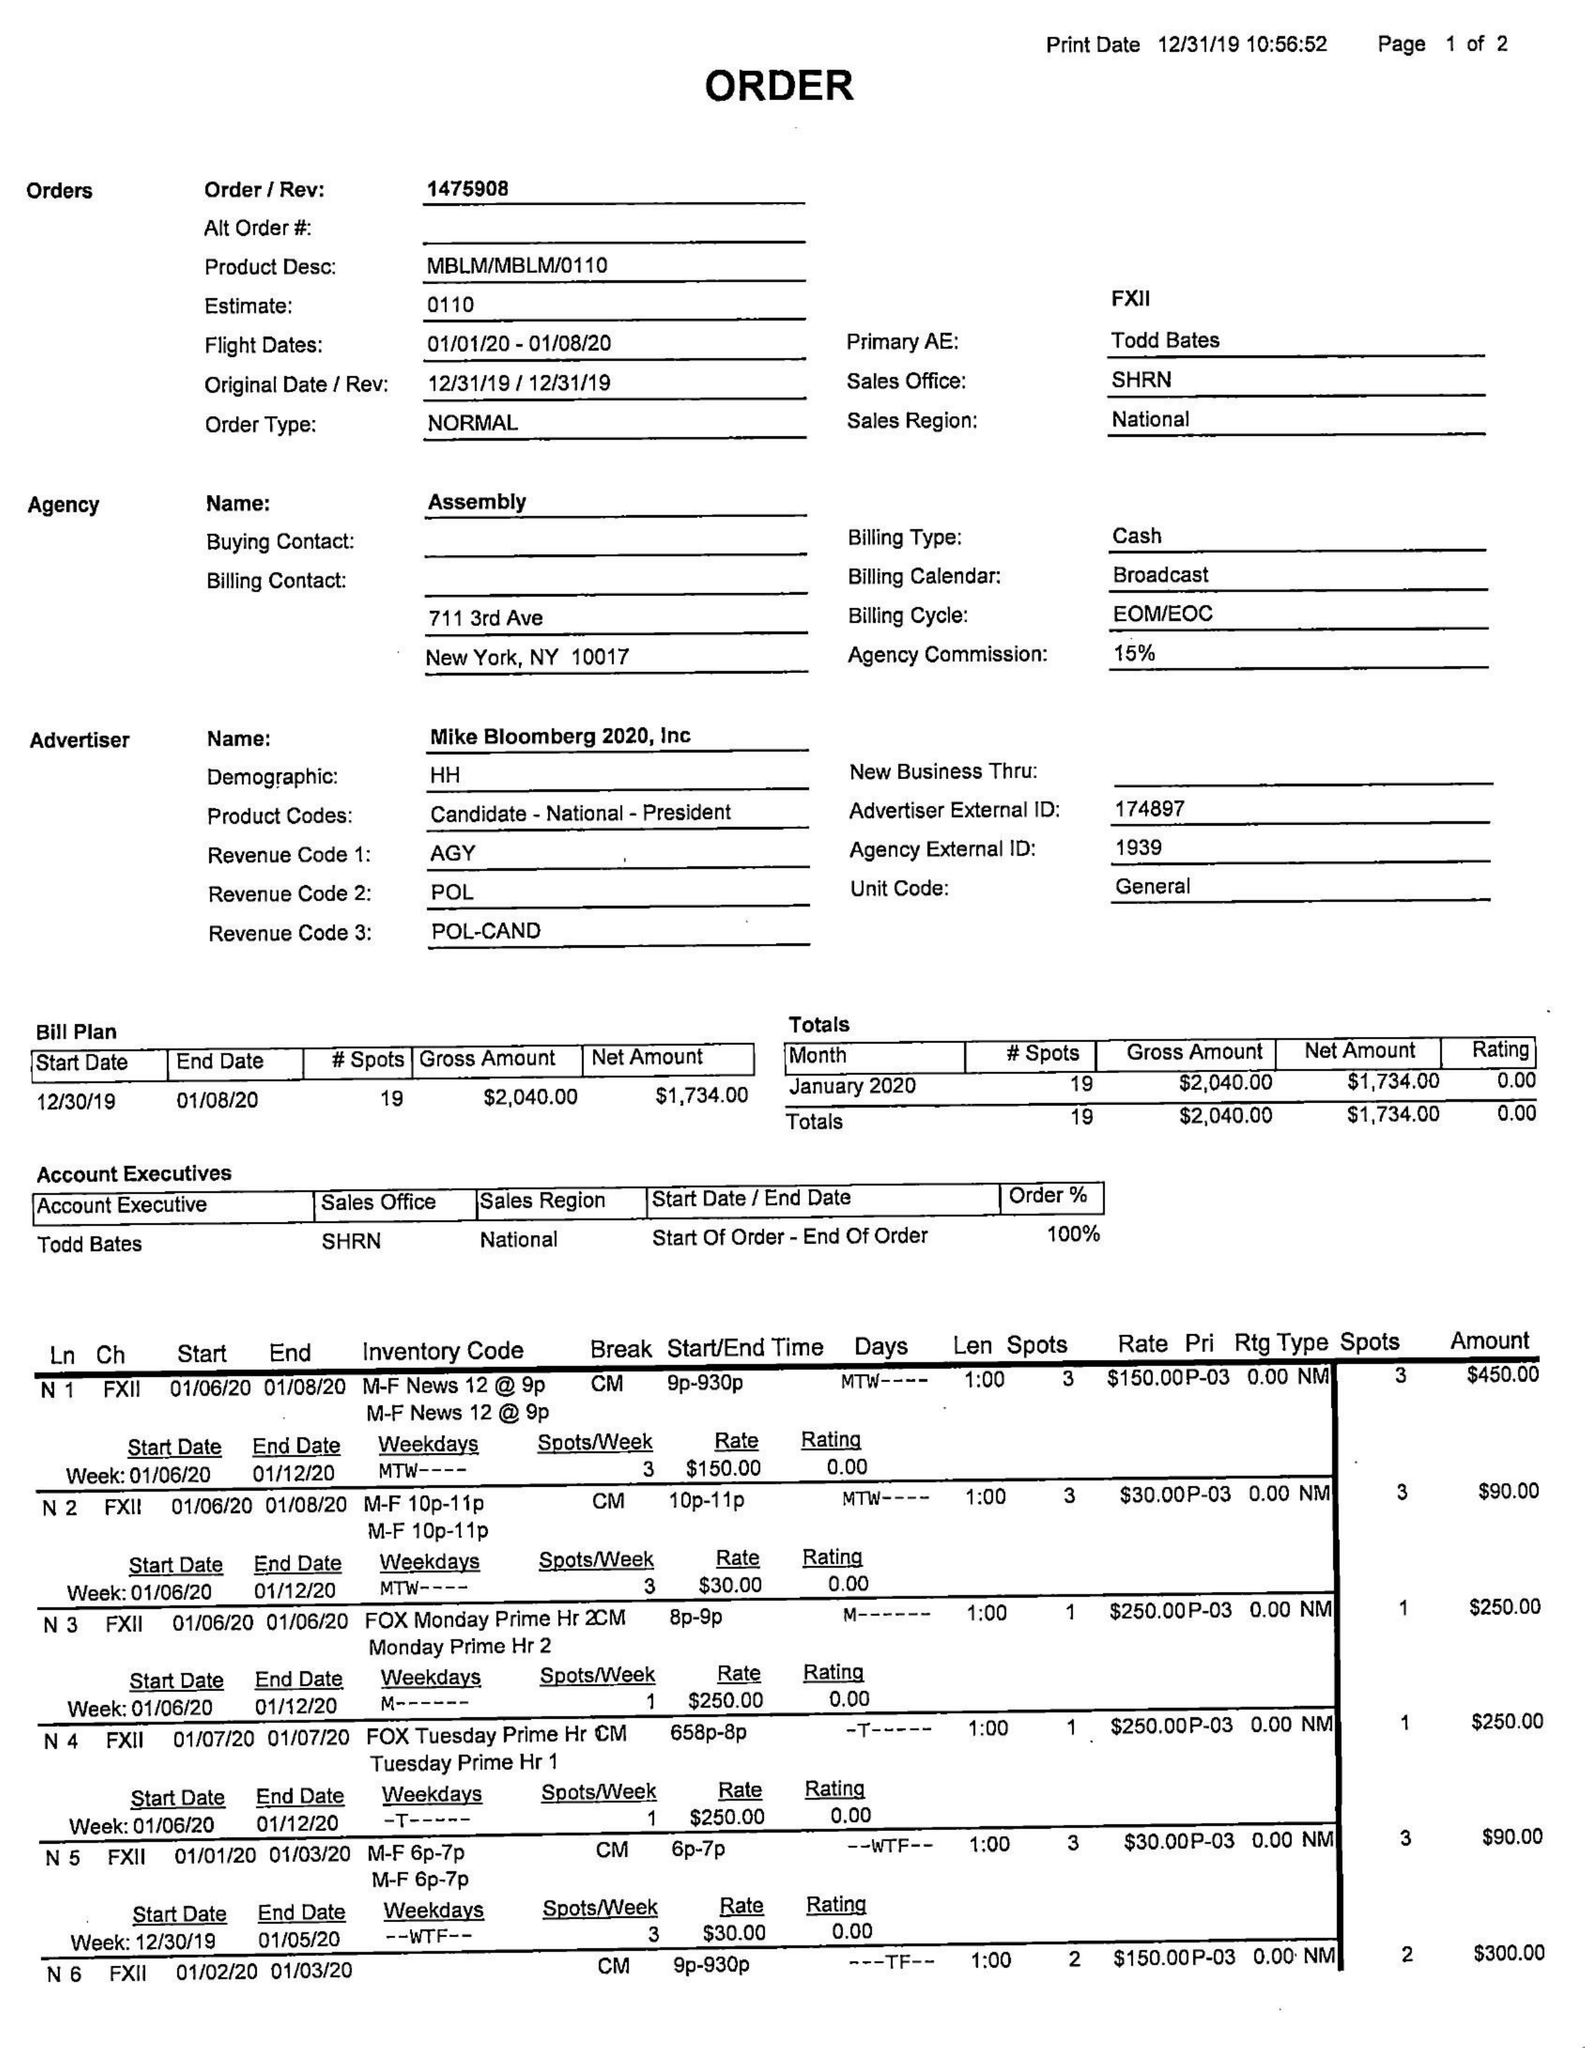What is the value for the contract_num?
Answer the question using a single word or phrase. 1475908 